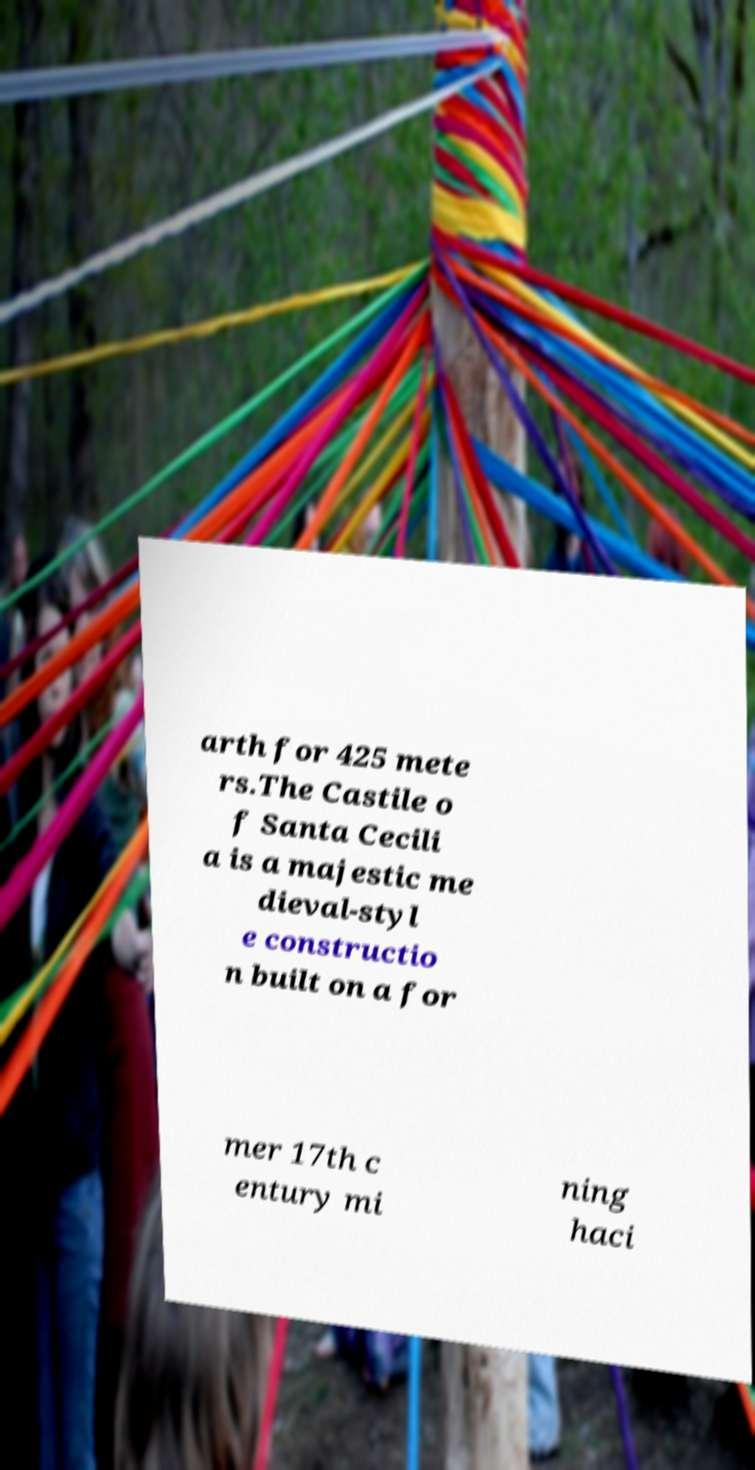Could you assist in decoding the text presented in this image and type it out clearly? arth for 425 mete rs.The Castile o f Santa Cecili a is a majestic me dieval-styl e constructio n built on a for mer 17th c entury mi ning haci 